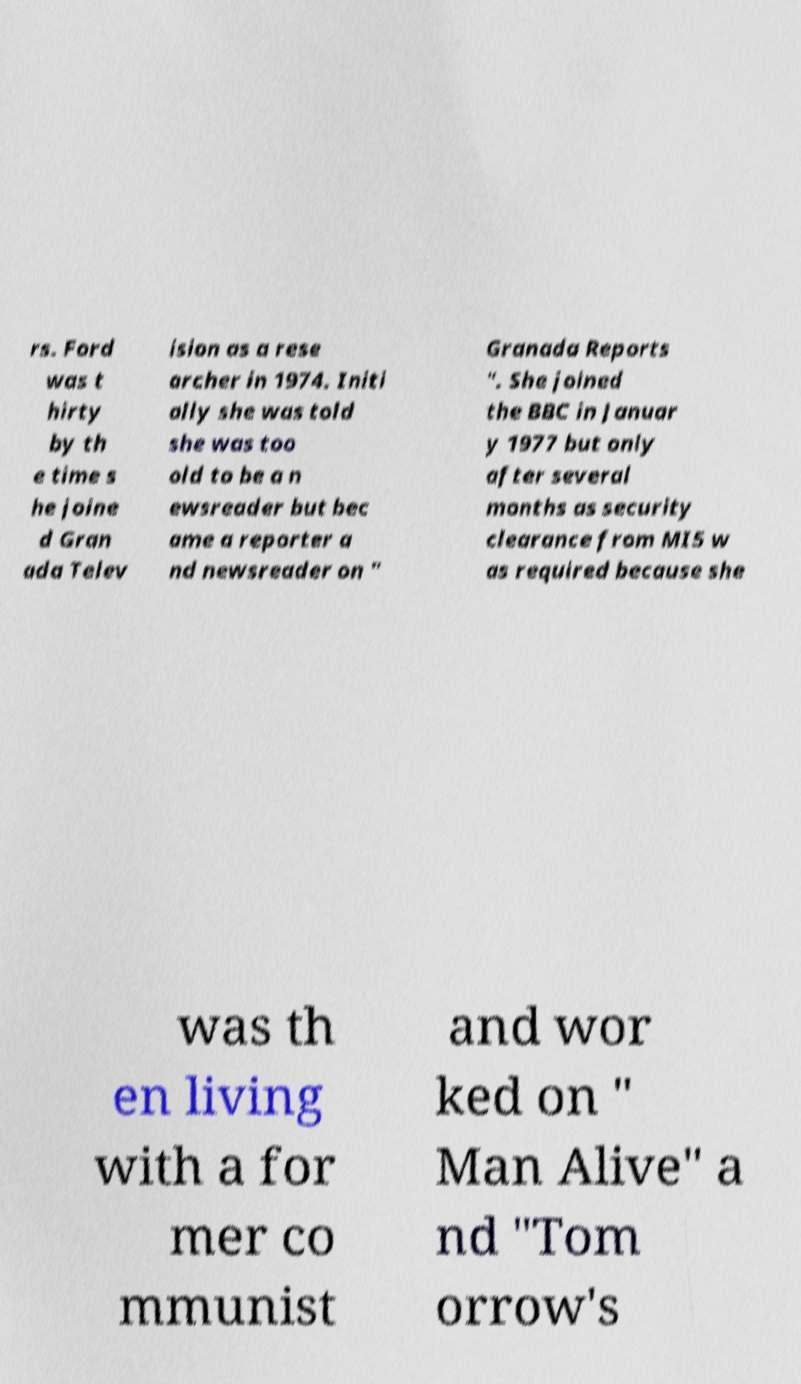Can you accurately transcribe the text from the provided image for me? rs. Ford was t hirty by th e time s he joine d Gran ada Telev ision as a rese archer in 1974. Initi ally she was told she was too old to be a n ewsreader but bec ame a reporter a nd newsreader on " Granada Reports ". She joined the BBC in Januar y 1977 but only after several months as security clearance from MI5 w as required because she was th en living with a for mer co mmunist and wor ked on " Man Alive" a nd "Tom orrow's 